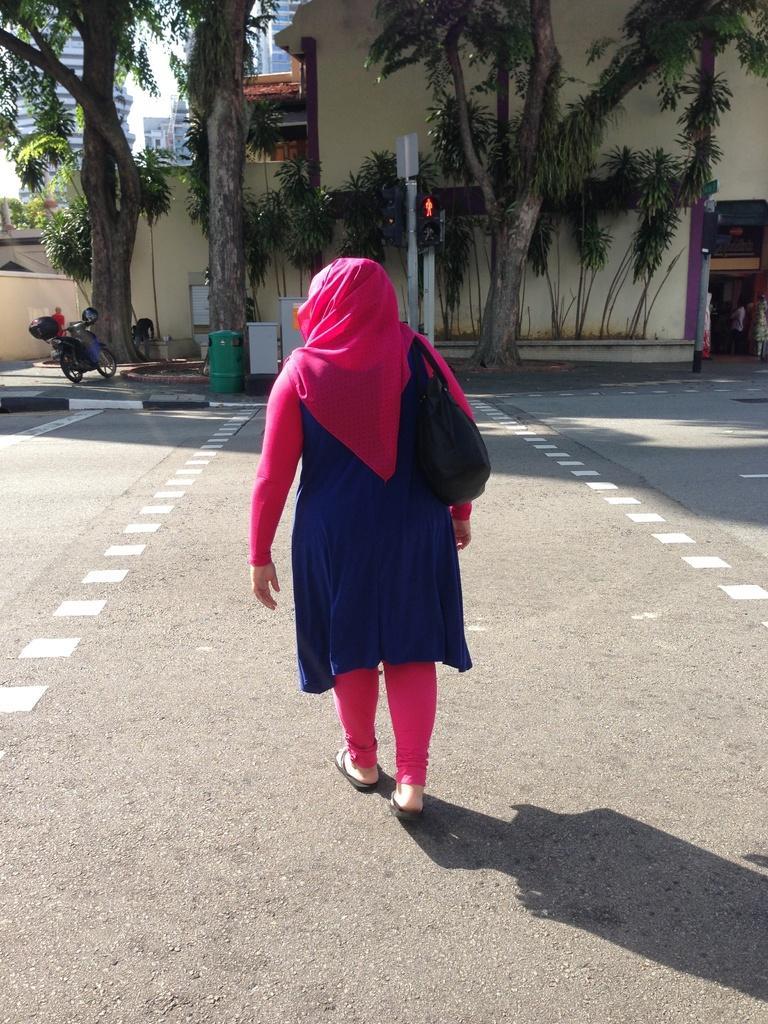Could you give a brief overview of what you see in this image? In this image I can see a person walking wearing blue and pink color dress. Background I can see a vehicle, trees in green color, a building in cream color and sky in white color. 